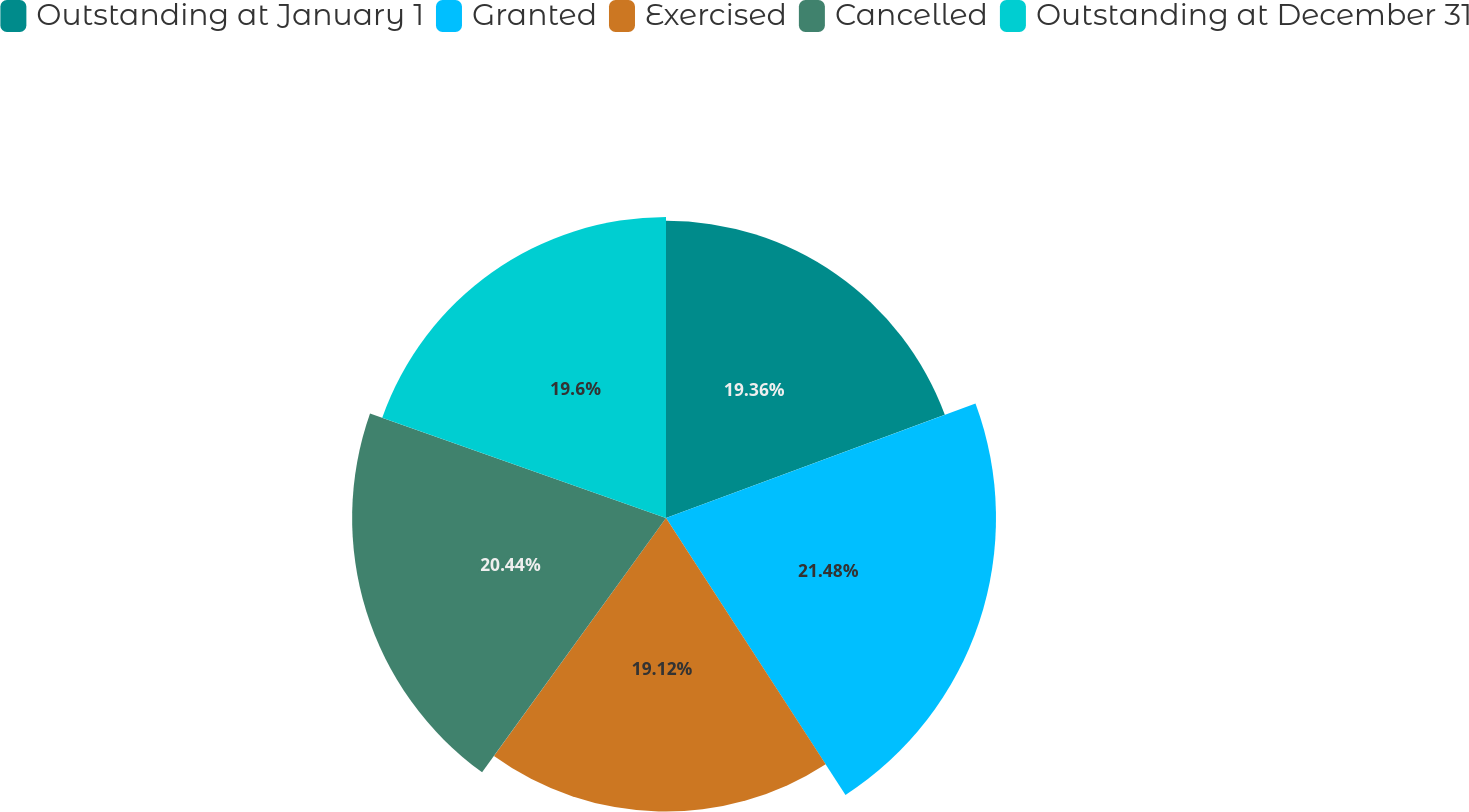Convert chart. <chart><loc_0><loc_0><loc_500><loc_500><pie_chart><fcel>Outstanding at January 1<fcel>Granted<fcel>Exercised<fcel>Cancelled<fcel>Outstanding at December 31<nl><fcel>19.36%<fcel>21.49%<fcel>19.12%<fcel>20.44%<fcel>19.6%<nl></chart> 